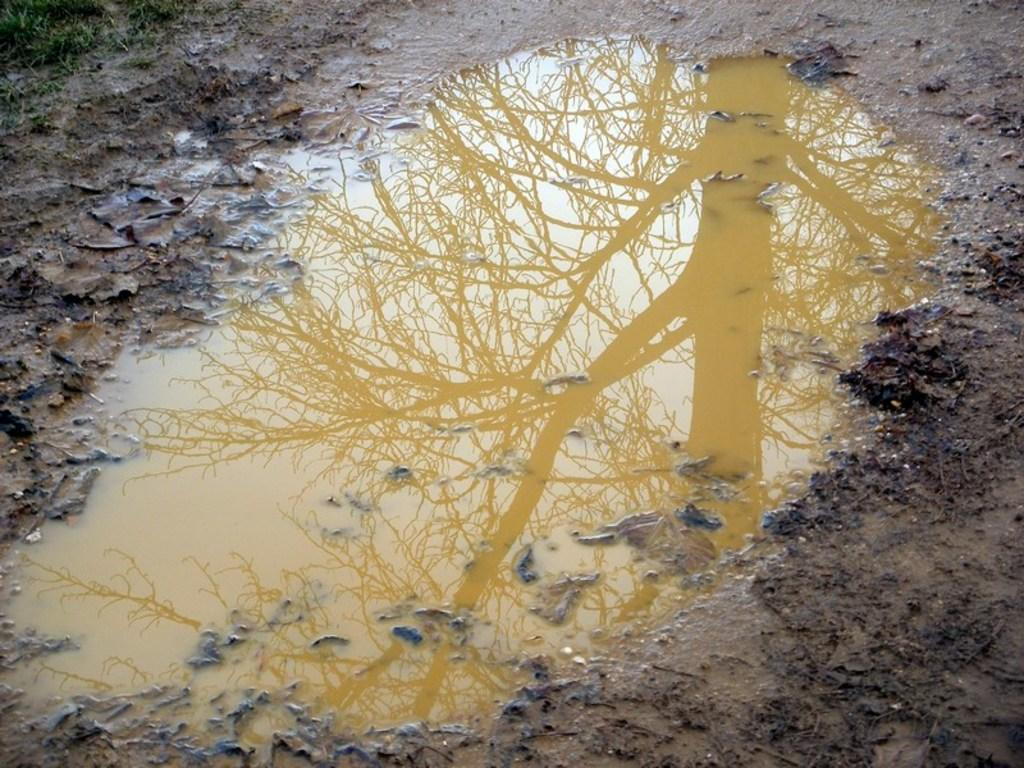What type of terrain is depicted in the image? There is mud in the image, suggesting a wet or damp environment. What natural element is also present in the image? There is water in the image. What can be observed in the water in the image? There is a tree reflection in the water. What month is depicted in the image? The image does not depict a specific month; it features mud, water, and a tree reflection in the water. Is there any indication of death or love in the image? There is no indication of death or love in the image; it primarily focuses on the natural elements of mud, water, and a tree reflection. 